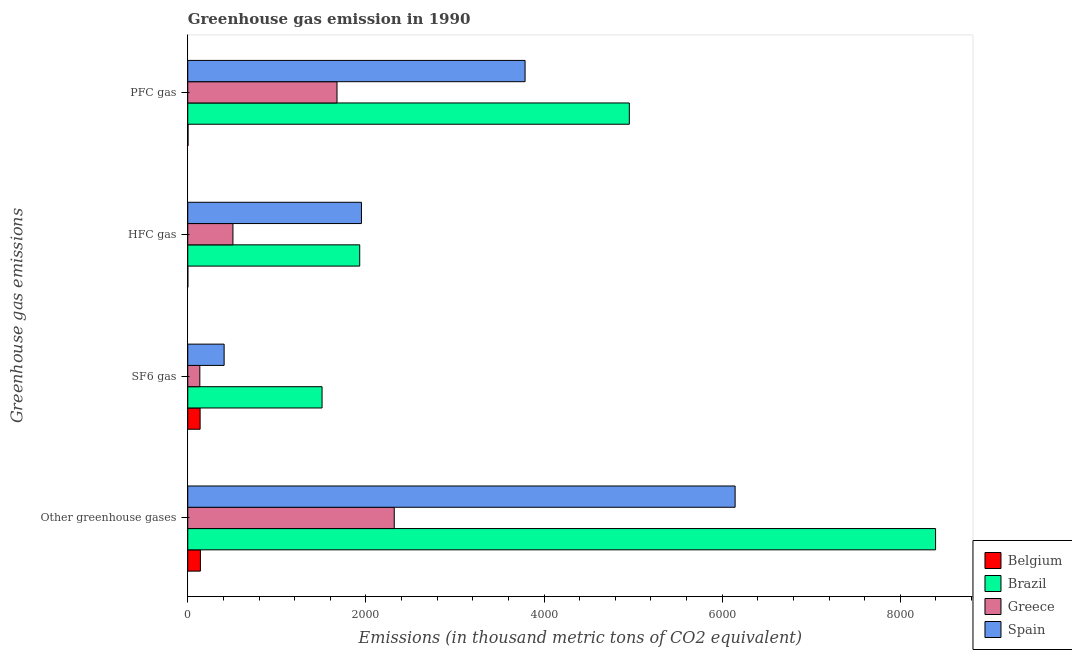How many different coloured bars are there?
Provide a short and direct response. 4. What is the label of the 4th group of bars from the top?
Keep it short and to the point. Other greenhouse gases. What is the emission of sf6 gas in Greece?
Your response must be concise. 135.4. Across all countries, what is the maximum emission of pfc gas?
Offer a very short reply. 4958.1. What is the total emission of sf6 gas in the graph?
Offer a terse response. 2190.1. What is the difference between the emission of sf6 gas in Brazil and that in Belgium?
Provide a short and direct response. 1369.4. What is the difference between the emission of hfc gas in Brazil and the emission of sf6 gas in Greece?
Offer a terse response. 1795.3. What is the average emission of greenhouse gases per country?
Your response must be concise. 4250.77. What is the difference between the emission of pfc gas and emission of sf6 gas in Greece?
Give a very brief answer. 1540.5. What is the ratio of the emission of hfc gas in Greece to that in Brazil?
Ensure brevity in your answer.  0.26. What is the difference between the highest and the second highest emission of pfc gas?
Give a very brief answer. 1170.7. What is the difference between the highest and the lowest emission of sf6 gas?
Provide a succinct answer. 1372.5. What does the 4th bar from the top in SF6 gas represents?
Your answer should be compact. Belgium. How many bars are there?
Your response must be concise. 16. Are all the bars in the graph horizontal?
Your response must be concise. Yes. How many countries are there in the graph?
Give a very brief answer. 4. What is the difference between two consecutive major ticks on the X-axis?
Keep it short and to the point. 2000. Does the graph contain any zero values?
Your answer should be very brief. No. Does the graph contain grids?
Offer a terse response. No. Where does the legend appear in the graph?
Keep it short and to the point. Bottom right. How are the legend labels stacked?
Your answer should be compact. Vertical. What is the title of the graph?
Your response must be concise. Greenhouse gas emission in 1990. What is the label or title of the X-axis?
Give a very brief answer. Emissions (in thousand metric tons of CO2 equivalent). What is the label or title of the Y-axis?
Make the answer very short. Greenhouse gas emissions. What is the Emissions (in thousand metric tons of CO2 equivalent) in Belgium in Other greenhouse gases?
Your answer should be very brief. 141.9. What is the Emissions (in thousand metric tons of CO2 equivalent) in Brazil in Other greenhouse gases?
Make the answer very short. 8396.7. What is the Emissions (in thousand metric tons of CO2 equivalent) of Greece in Other greenhouse gases?
Your answer should be very brief. 2318.5. What is the Emissions (in thousand metric tons of CO2 equivalent) in Spain in Other greenhouse gases?
Ensure brevity in your answer.  6146. What is the Emissions (in thousand metric tons of CO2 equivalent) of Belgium in SF6 gas?
Give a very brief answer. 138.5. What is the Emissions (in thousand metric tons of CO2 equivalent) of Brazil in SF6 gas?
Provide a short and direct response. 1507.9. What is the Emissions (in thousand metric tons of CO2 equivalent) of Greece in SF6 gas?
Offer a very short reply. 135.4. What is the Emissions (in thousand metric tons of CO2 equivalent) in Spain in SF6 gas?
Your answer should be compact. 408.3. What is the Emissions (in thousand metric tons of CO2 equivalent) in Belgium in HFC gas?
Your answer should be compact. 0.5. What is the Emissions (in thousand metric tons of CO2 equivalent) in Brazil in HFC gas?
Provide a short and direct response. 1930.7. What is the Emissions (in thousand metric tons of CO2 equivalent) in Greece in HFC gas?
Ensure brevity in your answer.  507.2. What is the Emissions (in thousand metric tons of CO2 equivalent) in Spain in HFC gas?
Offer a very short reply. 1950.3. What is the Emissions (in thousand metric tons of CO2 equivalent) in Brazil in PFC gas?
Give a very brief answer. 4958.1. What is the Emissions (in thousand metric tons of CO2 equivalent) in Greece in PFC gas?
Your answer should be compact. 1675.9. What is the Emissions (in thousand metric tons of CO2 equivalent) in Spain in PFC gas?
Your answer should be very brief. 3787.4. Across all Greenhouse gas emissions, what is the maximum Emissions (in thousand metric tons of CO2 equivalent) of Belgium?
Ensure brevity in your answer.  141.9. Across all Greenhouse gas emissions, what is the maximum Emissions (in thousand metric tons of CO2 equivalent) of Brazil?
Your response must be concise. 8396.7. Across all Greenhouse gas emissions, what is the maximum Emissions (in thousand metric tons of CO2 equivalent) of Greece?
Offer a terse response. 2318.5. Across all Greenhouse gas emissions, what is the maximum Emissions (in thousand metric tons of CO2 equivalent) of Spain?
Make the answer very short. 6146. Across all Greenhouse gas emissions, what is the minimum Emissions (in thousand metric tons of CO2 equivalent) of Brazil?
Ensure brevity in your answer.  1507.9. Across all Greenhouse gas emissions, what is the minimum Emissions (in thousand metric tons of CO2 equivalent) in Greece?
Offer a terse response. 135.4. Across all Greenhouse gas emissions, what is the minimum Emissions (in thousand metric tons of CO2 equivalent) in Spain?
Provide a succinct answer. 408.3. What is the total Emissions (in thousand metric tons of CO2 equivalent) in Belgium in the graph?
Offer a very short reply. 283.8. What is the total Emissions (in thousand metric tons of CO2 equivalent) of Brazil in the graph?
Keep it short and to the point. 1.68e+04. What is the total Emissions (in thousand metric tons of CO2 equivalent) in Greece in the graph?
Give a very brief answer. 4637. What is the total Emissions (in thousand metric tons of CO2 equivalent) of Spain in the graph?
Your answer should be very brief. 1.23e+04. What is the difference between the Emissions (in thousand metric tons of CO2 equivalent) in Belgium in Other greenhouse gases and that in SF6 gas?
Your response must be concise. 3.4. What is the difference between the Emissions (in thousand metric tons of CO2 equivalent) in Brazil in Other greenhouse gases and that in SF6 gas?
Your answer should be compact. 6888.8. What is the difference between the Emissions (in thousand metric tons of CO2 equivalent) in Greece in Other greenhouse gases and that in SF6 gas?
Your answer should be compact. 2183.1. What is the difference between the Emissions (in thousand metric tons of CO2 equivalent) in Spain in Other greenhouse gases and that in SF6 gas?
Your answer should be compact. 5737.7. What is the difference between the Emissions (in thousand metric tons of CO2 equivalent) of Belgium in Other greenhouse gases and that in HFC gas?
Your answer should be compact. 141.4. What is the difference between the Emissions (in thousand metric tons of CO2 equivalent) in Brazil in Other greenhouse gases and that in HFC gas?
Your answer should be very brief. 6466. What is the difference between the Emissions (in thousand metric tons of CO2 equivalent) of Greece in Other greenhouse gases and that in HFC gas?
Give a very brief answer. 1811.3. What is the difference between the Emissions (in thousand metric tons of CO2 equivalent) in Spain in Other greenhouse gases and that in HFC gas?
Provide a short and direct response. 4195.7. What is the difference between the Emissions (in thousand metric tons of CO2 equivalent) in Belgium in Other greenhouse gases and that in PFC gas?
Give a very brief answer. 139. What is the difference between the Emissions (in thousand metric tons of CO2 equivalent) in Brazil in Other greenhouse gases and that in PFC gas?
Ensure brevity in your answer.  3438.6. What is the difference between the Emissions (in thousand metric tons of CO2 equivalent) of Greece in Other greenhouse gases and that in PFC gas?
Give a very brief answer. 642.6. What is the difference between the Emissions (in thousand metric tons of CO2 equivalent) of Spain in Other greenhouse gases and that in PFC gas?
Your answer should be compact. 2358.6. What is the difference between the Emissions (in thousand metric tons of CO2 equivalent) in Belgium in SF6 gas and that in HFC gas?
Give a very brief answer. 138. What is the difference between the Emissions (in thousand metric tons of CO2 equivalent) in Brazil in SF6 gas and that in HFC gas?
Your answer should be very brief. -422.8. What is the difference between the Emissions (in thousand metric tons of CO2 equivalent) in Greece in SF6 gas and that in HFC gas?
Offer a terse response. -371.8. What is the difference between the Emissions (in thousand metric tons of CO2 equivalent) in Spain in SF6 gas and that in HFC gas?
Give a very brief answer. -1542. What is the difference between the Emissions (in thousand metric tons of CO2 equivalent) of Belgium in SF6 gas and that in PFC gas?
Offer a very short reply. 135.6. What is the difference between the Emissions (in thousand metric tons of CO2 equivalent) of Brazil in SF6 gas and that in PFC gas?
Your answer should be very brief. -3450.2. What is the difference between the Emissions (in thousand metric tons of CO2 equivalent) of Greece in SF6 gas and that in PFC gas?
Offer a terse response. -1540.5. What is the difference between the Emissions (in thousand metric tons of CO2 equivalent) in Spain in SF6 gas and that in PFC gas?
Your response must be concise. -3379.1. What is the difference between the Emissions (in thousand metric tons of CO2 equivalent) of Brazil in HFC gas and that in PFC gas?
Offer a very short reply. -3027.4. What is the difference between the Emissions (in thousand metric tons of CO2 equivalent) of Greece in HFC gas and that in PFC gas?
Provide a short and direct response. -1168.7. What is the difference between the Emissions (in thousand metric tons of CO2 equivalent) in Spain in HFC gas and that in PFC gas?
Provide a succinct answer. -1837.1. What is the difference between the Emissions (in thousand metric tons of CO2 equivalent) in Belgium in Other greenhouse gases and the Emissions (in thousand metric tons of CO2 equivalent) in Brazil in SF6 gas?
Your response must be concise. -1366. What is the difference between the Emissions (in thousand metric tons of CO2 equivalent) of Belgium in Other greenhouse gases and the Emissions (in thousand metric tons of CO2 equivalent) of Spain in SF6 gas?
Make the answer very short. -266.4. What is the difference between the Emissions (in thousand metric tons of CO2 equivalent) of Brazil in Other greenhouse gases and the Emissions (in thousand metric tons of CO2 equivalent) of Greece in SF6 gas?
Keep it short and to the point. 8261.3. What is the difference between the Emissions (in thousand metric tons of CO2 equivalent) in Brazil in Other greenhouse gases and the Emissions (in thousand metric tons of CO2 equivalent) in Spain in SF6 gas?
Your answer should be very brief. 7988.4. What is the difference between the Emissions (in thousand metric tons of CO2 equivalent) in Greece in Other greenhouse gases and the Emissions (in thousand metric tons of CO2 equivalent) in Spain in SF6 gas?
Ensure brevity in your answer.  1910.2. What is the difference between the Emissions (in thousand metric tons of CO2 equivalent) in Belgium in Other greenhouse gases and the Emissions (in thousand metric tons of CO2 equivalent) in Brazil in HFC gas?
Keep it short and to the point. -1788.8. What is the difference between the Emissions (in thousand metric tons of CO2 equivalent) of Belgium in Other greenhouse gases and the Emissions (in thousand metric tons of CO2 equivalent) of Greece in HFC gas?
Your answer should be very brief. -365.3. What is the difference between the Emissions (in thousand metric tons of CO2 equivalent) of Belgium in Other greenhouse gases and the Emissions (in thousand metric tons of CO2 equivalent) of Spain in HFC gas?
Your answer should be compact. -1808.4. What is the difference between the Emissions (in thousand metric tons of CO2 equivalent) in Brazil in Other greenhouse gases and the Emissions (in thousand metric tons of CO2 equivalent) in Greece in HFC gas?
Ensure brevity in your answer.  7889.5. What is the difference between the Emissions (in thousand metric tons of CO2 equivalent) of Brazil in Other greenhouse gases and the Emissions (in thousand metric tons of CO2 equivalent) of Spain in HFC gas?
Provide a short and direct response. 6446.4. What is the difference between the Emissions (in thousand metric tons of CO2 equivalent) of Greece in Other greenhouse gases and the Emissions (in thousand metric tons of CO2 equivalent) of Spain in HFC gas?
Your response must be concise. 368.2. What is the difference between the Emissions (in thousand metric tons of CO2 equivalent) in Belgium in Other greenhouse gases and the Emissions (in thousand metric tons of CO2 equivalent) in Brazil in PFC gas?
Ensure brevity in your answer.  -4816.2. What is the difference between the Emissions (in thousand metric tons of CO2 equivalent) in Belgium in Other greenhouse gases and the Emissions (in thousand metric tons of CO2 equivalent) in Greece in PFC gas?
Offer a terse response. -1534. What is the difference between the Emissions (in thousand metric tons of CO2 equivalent) of Belgium in Other greenhouse gases and the Emissions (in thousand metric tons of CO2 equivalent) of Spain in PFC gas?
Your answer should be very brief. -3645.5. What is the difference between the Emissions (in thousand metric tons of CO2 equivalent) of Brazil in Other greenhouse gases and the Emissions (in thousand metric tons of CO2 equivalent) of Greece in PFC gas?
Ensure brevity in your answer.  6720.8. What is the difference between the Emissions (in thousand metric tons of CO2 equivalent) of Brazil in Other greenhouse gases and the Emissions (in thousand metric tons of CO2 equivalent) of Spain in PFC gas?
Make the answer very short. 4609.3. What is the difference between the Emissions (in thousand metric tons of CO2 equivalent) in Greece in Other greenhouse gases and the Emissions (in thousand metric tons of CO2 equivalent) in Spain in PFC gas?
Provide a short and direct response. -1468.9. What is the difference between the Emissions (in thousand metric tons of CO2 equivalent) of Belgium in SF6 gas and the Emissions (in thousand metric tons of CO2 equivalent) of Brazil in HFC gas?
Your answer should be very brief. -1792.2. What is the difference between the Emissions (in thousand metric tons of CO2 equivalent) of Belgium in SF6 gas and the Emissions (in thousand metric tons of CO2 equivalent) of Greece in HFC gas?
Provide a short and direct response. -368.7. What is the difference between the Emissions (in thousand metric tons of CO2 equivalent) of Belgium in SF6 gas and the Emissions (in thousand metric tons of CO2 equivalent) of Spain in HFC gas?
Your answer should be very brief. -1811.8. What is the difference between the Emissions (in thousand metric tons of CO2 equivalent) in Brazil in SF6 gas and the Emissions (in thousand metric tons of CO2 equivalent) in Greece in HFC gas?
Provide a short and direct response. 1000.7. What is the difference between the Emissions (in thousand metric tons of CO2 equivalent) in Brazil in SF6 gas and the Emissions (in thousand metric tons of CO2 equivalent) in Spain in HFC gas?
Keep it short and to the point. -442.4. What is the difference between the Emissions (in thousand metric tons of CO2 equivalent) in Greece in SF6 gas and the Emissions (in thousand metric tons of CO2 equivalent) in Spain in HFC gas?
Offer a terse response. -1814.9. What is the difference between the Emissions (in thousand metric tons of CO2 equivalent) in Belgium in SF6 gas and the Emissions (in thousand metric tons of CO2 equivalent) in Brazil in PFC gas?
Offer a very short reply. -4819.6. What is the difference between the Emissions (in thousand metric tons of CO2 equivalent) in Belgium in SF6 gas and the Emissions (in thousand metric tons of CO2 equivalent) in Greece in PFC gas?
Ensure brevity in your answer.  -1537.4. What is the difference between the Emissions (in thousand metric tons of CO2 equivalent) in Belgium in SF6 gas and the Emissions (in thousand metric tons of CO2 equivalent) in Spain in PFC gas?
Your answer should be compact. -3648.9. What is the difference between the Emissions (in thousand metric tons of CO2 equivalent) in Brazil in SF6 gas and the Emissions (in thousand metric tons of CO2 equivalent) in Greece in PFC gas?
Offer a terse response. -168. What is the difference between the Emissions (in thousand metric tons of CO2 equivalent) of Brazil in SF6 gas and the Emissions (in thousand metric tons of CO2 equivalent) of Spain in PFC gas?
Ensure brevity in your answer.  -2279.5. What is the difference between the Emissions (in thousand metric tons of CO2 equivalent) in Greece in SF6 gas and the Emissions (in thousand metric tons of CO2 equivalent) in Spain in PFC gas?
Provide a succinct answer. -3652. What is the difference between the Emissions (in thousand metric tons of CO2 equivalent) of Belgium in HFC gas and the Emissions (in thousand metric tons of CO2 equivalent) of Brazil in PFC gas?
Provide a succinct answer. -4957.6. What is the difference between the Emissions (in thousand metric tons of CO2 equivalent) of Belgium in HFC gas and the Emissions (in thousand metric tons of CO2 equivalent) of Greece in PFC gas?
Your answer should be very brief. -1675.4. What is the difference between the Emissions (in thousand metric tons of CO2 equivalent) of Belgium in HFC gas and the Emissions (in thousand metric tons of CO2 equivalent) of Spain in PFC gas?
Your response must be concise. -3786.9. What is the difference between the Emissions (in thousand metric tons of CO2 equivalent) in Brazil in HFC gas and the Emissions (in thousand metric tons of CO2 equivalent) in Greece in PFC gas?
Make the answer very short. 254.8. What is the difference between the Emissions (in thousand metric tons of CO2 equivalent) of Brazil in HFC gas and the Emissions (in thousand metric tons of CO2 equivalent) of Spain in PFC gas?
Keep it short and to the point. -1856.7. What is the difference between the Emissions (in thousand metric tons of CO2 equivalent) of Greece in HFC gas and the Emissions (in thousand metric tons of CO2 equivalent) of Spain in PFC gas?
Keep it short and to the point. -3280.2. What is the average Emissions (in thousand metric tons of CO2 equivalent) of Belgium per Greenhouse gas emissions?
Keep it short and to the point. 70.95. What is the average Emissions (in thousand metric tons of CO2 equivalent) in Brazil per Greenhouse gas emissions?
Your response must be concise. 4198.35. What is the average Emissions (in thousand metric tons of CO2 equivalent) in Greece per Greenhouse gas emissions?
Provide a succinct answer. 1159.25. What is the average Emissions (in thousand metric tons of CO2 equivalent) of Spain per Greenhouse gas emissions?
Give a very brief answer. 3073. What is the difference between the Emissions (in thousand metric tons of CO2 equivalent) in Belgium and Emissions (in thousand metric tons of CO2 equivalent) in Brazil in Other greenhouse gases?
Provide a short and direct response. -8254.8. What is the difference between the Emissions (in thousand metric tons of CO2 equivalent) in Belgium and Emissions (in thousand metric tons of CO2 equivalent) in Greece in Other greenhouse gases?
Make the answer very short. -2176.6. What is the difference between the Emissions (in thousand metric tons of CO2 equivalent) in Belgium and Emissions (in thousand metric tons of CO2 equivalent) in Spain in Other greenhouse gases?
Offer a terse response. -6004.1. What is the difference between the Emissions (in thousand metric tons of CO2 equivalent) in Brazil and Emissions (in thousand metric tons of CO2 equivalent) in Greece in Other greenhouse gases?
Make the answer very short. 6078.2. What is the difference between the Emissions (in thousand metric tons of CO2 equivalent) of Brazil and Emissions (in thousand metric tons of CO2 equivalent) of Spain in Other greenhouse gases?
Offer a terse response. 2250.7. What is the difference between the Emissions (in thousand metric tons of CO2 equivalent) of Greece and Emissions (in thousand metric tons of CO2 equivalent) of Spain in Other greenhouse gases?
Offer a very short reply. -3827.5. What is the difference between the Emissions (in thousand metric tons of CO2 equivalent) in Belgium and Emissions (in thousand metric tons of CO2 equivalent) in Brazil in SF6 gas?
Make the answer very short. -1369.4. What is the difference between the Emissions (in thousand metric tons of CO2 equivalent) in Belgium and Emissions (in thousand metric tons of CO2 equivalent) in Greece in SF6 gas?
Offer a terse response. 3.1. What is the difference between the Emissions (in thousand metric tons of CO2 equivalent) of Belgium and Emissions (in thousand metric tons of CO2 equivalent) of Spain in SF6 gas?
Provide a succinct answer. -269.8. What is the difference between the Emissions (in thousand metric tons of CO2 equivalent) in Brazil and Emissions (in thousand metric tons of CO2 equivalent) in Greece in SF6 gas?
Ensure brevity in your answer.  1372.5. What is the difference between the Emissions (in thousand metric tons of CO2 equivalent) in Brazil and Emissions (in thousand metric tons of CO2 equivalent) in Spain in SF6 gas?
Your answer should be very brief. 1099.6. What is the difference between the Emissions (in thousand metric tons of CO2 equivalent) of Greece and Emissions (in thousand metric tons of CO2 equivalent) of Spain in SF6 gas?
Keep it short and to the point. -272.9. What is the difference between the Emissions (in thousand metric tons of CO2 equivalent) of Belgium and Emissions (in thousand metric tons of CO2 equivalent) of Brazil in HFC gas?
Your answer should be compact. -1930.2. What is the difference between the Emissions (in thousand metric tons of CO2 equivalent) in Belgium and Emissions (in thousand metric tons of CO2 equivalent) in Greece in HFC gas?
Make the answer very short. -506.7. What is the difference between the Emissions (in thousand metric tons of CO2 equivalent) of Belgium and Emissions (in thousand metric tons of CO2 equivalent) of Spain in HFC gas?
Provide a short and direct response. -1949.8. What is the difference between the Emissions (in thousand metric tons of CO2 equivalent) of Brazil and Emissions (in thousand metric tons of CO2 equivalent) of Greece in HFC gas?
Offer a terse response. 1423.5. What is the difference between the Emissions (in thousand metric tons of CO2 equivalent) of Brazil and Emissions (in thousand metric tons of CO2 equivalent) of Spain in HFC gas?
Your answer should be compact. -19.6. What is the difference between the Emissions (in thousand metric tons of CO2 equivalent) of Greece and Emissions (in thousand metric tons of CO2 equivalent) of Spain in HFC gas?
Ensure brevity in your answer.  -1443.1. What is the difference between the Emissions (in thousand metric tons of CO2 equivalent) in Belgium and Emissions (in thousand metric tons of CO2 equivalent) in Brazil in PFC gas?
Provide a short and direct response. -4955.2. What is the difference between the Emissions (in thousand metric tons of CO2 equivalent) of Belgium and Emissions (in thousand metric tons of CO2 equivalent) of Greece in PFC gas?
Make the answer very short. -1673. What is the difference between the Emissions (in thousand metric tons of CO2 equivalent) of Belgium and Emissions (in thousand metric tons of CO2 equivalent) of Spain in PFC gas?
Make the answer very short. -3784.5. What is the difference between the Emissions (in thousand metric tons of CO2 equivalent) in Brazil and Emissions (in thousand metric tons of CO2 equivalent) in Greece in PFC gas?
Keep it short and to the point. 3282.2. What is the difference between the Emissions (in thousand metric tons of CO2 equivalent) of Brazil and Emissions (in thousand metric tons of CO2 equivalent) of Spain in PFC gas?
Make the answer very short. 1170.7. What is the difference between the Emissions (in thousand metric tons of CO2 equivalent) of Greece and Emissions (in thousand metric tons of CO2 equivalent) of Spain in PFC gas?
Provide a short and direct response. -2111.5. What is the ratio of the Emissions (in thousand metric tons of CO2 equivalent) in Belgium in Other greenhouse gases to that in SF6 gas?
Provide a succinct answer. 1.02. What is the ratio of the Emissions (in thousand metric tons of CO2 equivalent) of Brazil in Other greenhouse gases to that in SF6 gas?
Keep it short and to the point. 5.57. What is the ratio of the Emissions (in thousand metric tons of CO2 equivalent) of Greece in Other greenhouse gases to that in SF6 gas?
Your answer should be very brief. 17.12. What is the ratio of the Emissions (in thousand metric tons of CO2 equivalent) in Spain in Other greenhouse gases to that in SF6 gas?
Your answer should be compact. 15.05. What is the ratio of the Emissions (in thousand metric tons of CO2 equivalent) in Belgium in Other greenhouse gases to that in HFC gas?
Give a very brief answer. 283.8. What is the ratio of the Emissions (in thousand metric tons of CO2 equivalent) of Brazil in Other greenhouse gases to that in HFC gas?
Provide a succinct answer. 4.35. What is the ratio of the Emissions (in thousand metric tons of CO2 equivalent) of Greece in Other greenhouse gases to that in HFC gas?
Ensure brevity in your answer.  4.57. What is the ratio of the Emissions (in thousand metric tons of CO2 equivalent) in Spain in Other greenhouse gases to that in HFC gas?
Offer a terse response. 3.15. What is the ratio of the Emissions (in thousand metric tons of CO2 equivalent) of Belgium in Other greenhouse gases to that in PFC gas?
Make the answer very short. 48.93. What is the ratio of the Emissions (in thousand metric tons of CO2 equivalent) in Brazil in Other greenhouse gases to that in PFC gas?
Offer a very short reply. 1.69. What is the ratio of the Emissions (in thousand metric tons of CO2 equivalent) in Greece in Other greenhouse gases to that in PFC gas?
Your answer should be very brief. 1.38. What is the ratio of the Emissions (in thousand metric tons of CO2 equivalent) in Spain in Other greenhouse gases to that in PFC gas?
Ensure brevity in your answer.  1.62. What is the ratio of the Emissions (in thousand metric tons of CO2 equivalent) of Belgium in SF6 gas to that in HFC gas?
Provide a short and direct response. 277. What is the ratio of the Emissions (in thousand metric tons of CO2 equivalent) of Brazil in SF6 gas to that in HFC gas?
Ensure brevity in your answer.  0.78. What is the ratio of the Emissions (in thousand metric tons of CO2 equivalent) in Greece in SF6 gas to that in HFC gas?
Make the answer very short. 0.27. What is the ratio of the Emissions (in thousand metric tons of CO2 equivalent) in Spain in SF6 gas to that in HFC gas?
Provide a short and direct response. 0.21. What is the ratio of the Emissions (in thousand metric tons of CO2 equivalent) of Belgium in SF6 gas to that in PFC gas?
Ensure brevity in your answer.  47.76. What is the ratio of the Emissions (in thousand metric tons of CO2 equivalent) of Brazil in SF6 gas to that in PFC gas?
Your answer should be compact. 0.3. What is the ratio of the Emissions (in thousand metric tons of CO2 equivalent) in Greece in SF6 gas to that in PFC gas?
Your answer should be very brief. 0.08. What is the ratio of the Emissions (in thousand metric tons of CO2 equivalent) of Spain in SF6 gas to that in PFC gas?
Provide a succinct answer. 0.11. What is the ratio of the Emissions (in thousand metric tons of CO2 equivalent) of Belgium in HFC gas to that in PFC gas?
Your answer should be very brief. 0.17. What is the ratio of the Emissions (in thousand metric tons of CO2 equivalent) in Brazil in HFC gas to that in PFC gas?
Your answer should be compact. 0.39. What is the ratio of the Emissions (in thousand metric tons of CO2 equivalent) of Greece in HFC gas to that in PFC gas?
Ensure brevity in your answer.  0.3. What is the ratio of the Emissions (in thousand metric tons of CO2 equivalent) in Spain in HFC gas to that in PFC gas?
Your answer should be compact. 0.51. What is the difference between the highest and the second highest Emissions (in thousand metric tons of CO2 equivalent) in Brazil?
Provide a succinct answer. 3438.6. What is the difference between the highest and the second highest Emissions (in thousand metric tons of CO2 equivalent) of Greece?
Offer a very short reply. 642.6. What is the difference between the highest and the second highest Emissions (in thousand metric tons of CO2 equivalent) in Spain?
Your response must be concise. 2358.6. What is the difference between the highest and the lowest Emissions (in thousand metric tons of CO2 equivalent) of Belgium?
Your response must be concise. 141.4. What is the difference between the highest and the lowest Emissions (in thousand metric tons of CO2 equivalent) of Brazil?
Your answer should be compact. 6888.8. What is the difference between the highest and the lowest Emissions (in thousand metric tons of CO2 equivalent) of Greece?
Offer a very short reply. 2183.1. What is the difference between the highest and the lowest Emissions (in thousand metric tons of CO2 equivalent) of Spain?
Provide a short and direct response. 5737.7. 